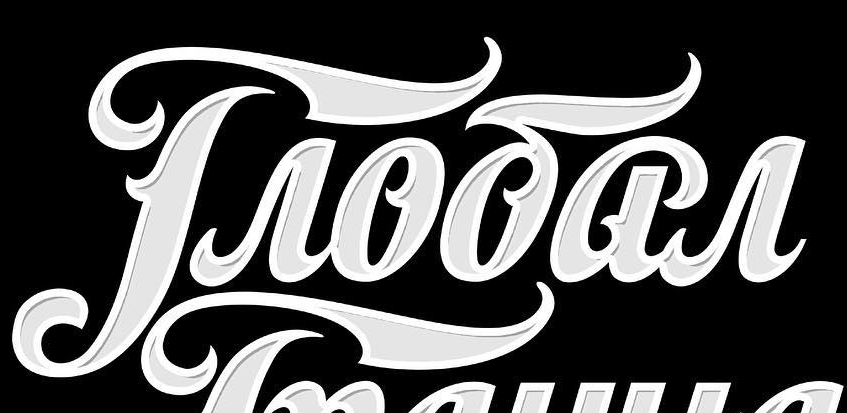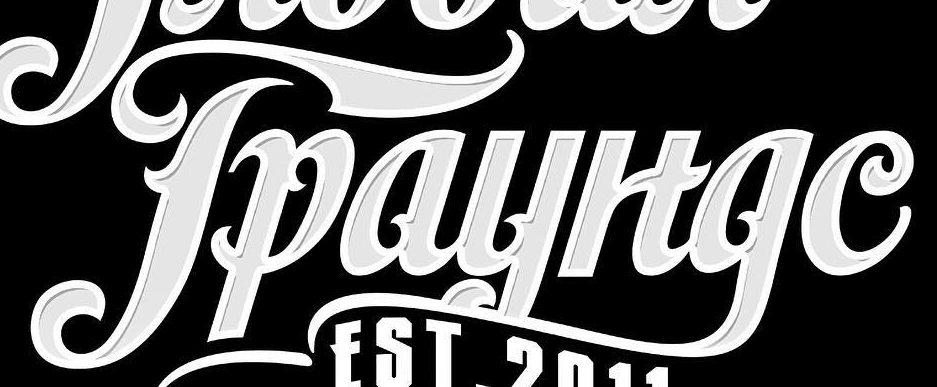What text appears in these images from left to right, separated by a semicolon? Troōar; Tpayltge 